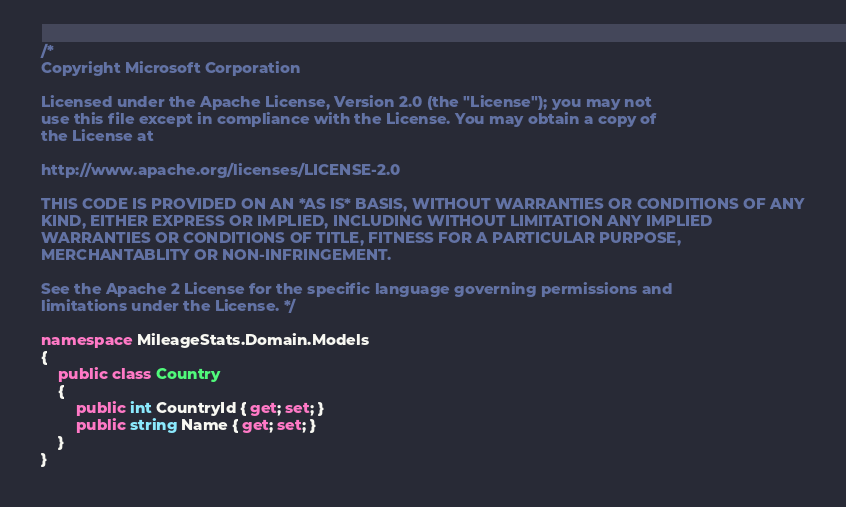Convert code to text. <code><loc_0><loc_0><loc_500><loc_500><_C#_>/*  
Copyright Microsoft Corporation

Licensed under the Apache License, Version 2.0 (the "License"); you may not
use this file except in compliance with the License. You may obtain a copy of
the License at 

http://www.apache.org/licenses/LICENSE-2.0 

THIS CODE IS PROVIDED ON AN *AS IS* BASIS, WITHOUT WARRANTIES OR CONDITIONS OF ANY
KIND, EITHER EXPRESS OR IMPLIED, INCLUDING WITHOUT LIMITATION ANY IMPLIED 
WARRANTIES OR CONDITIONS OF TITLE, FITNESS FOR A PARTICULAR PURPOSE, 
MERCHANTABLITY OR NON-INFRINGEMENT. 

See the Apache 2 License for the specific language governing permissions and
limitations under the License. */

namespace MileageStats.Domain.Models
{
    public class Country
    {
        public int CountryId { get; set; }
        public string Name { get; set; }
    }
}</code> 